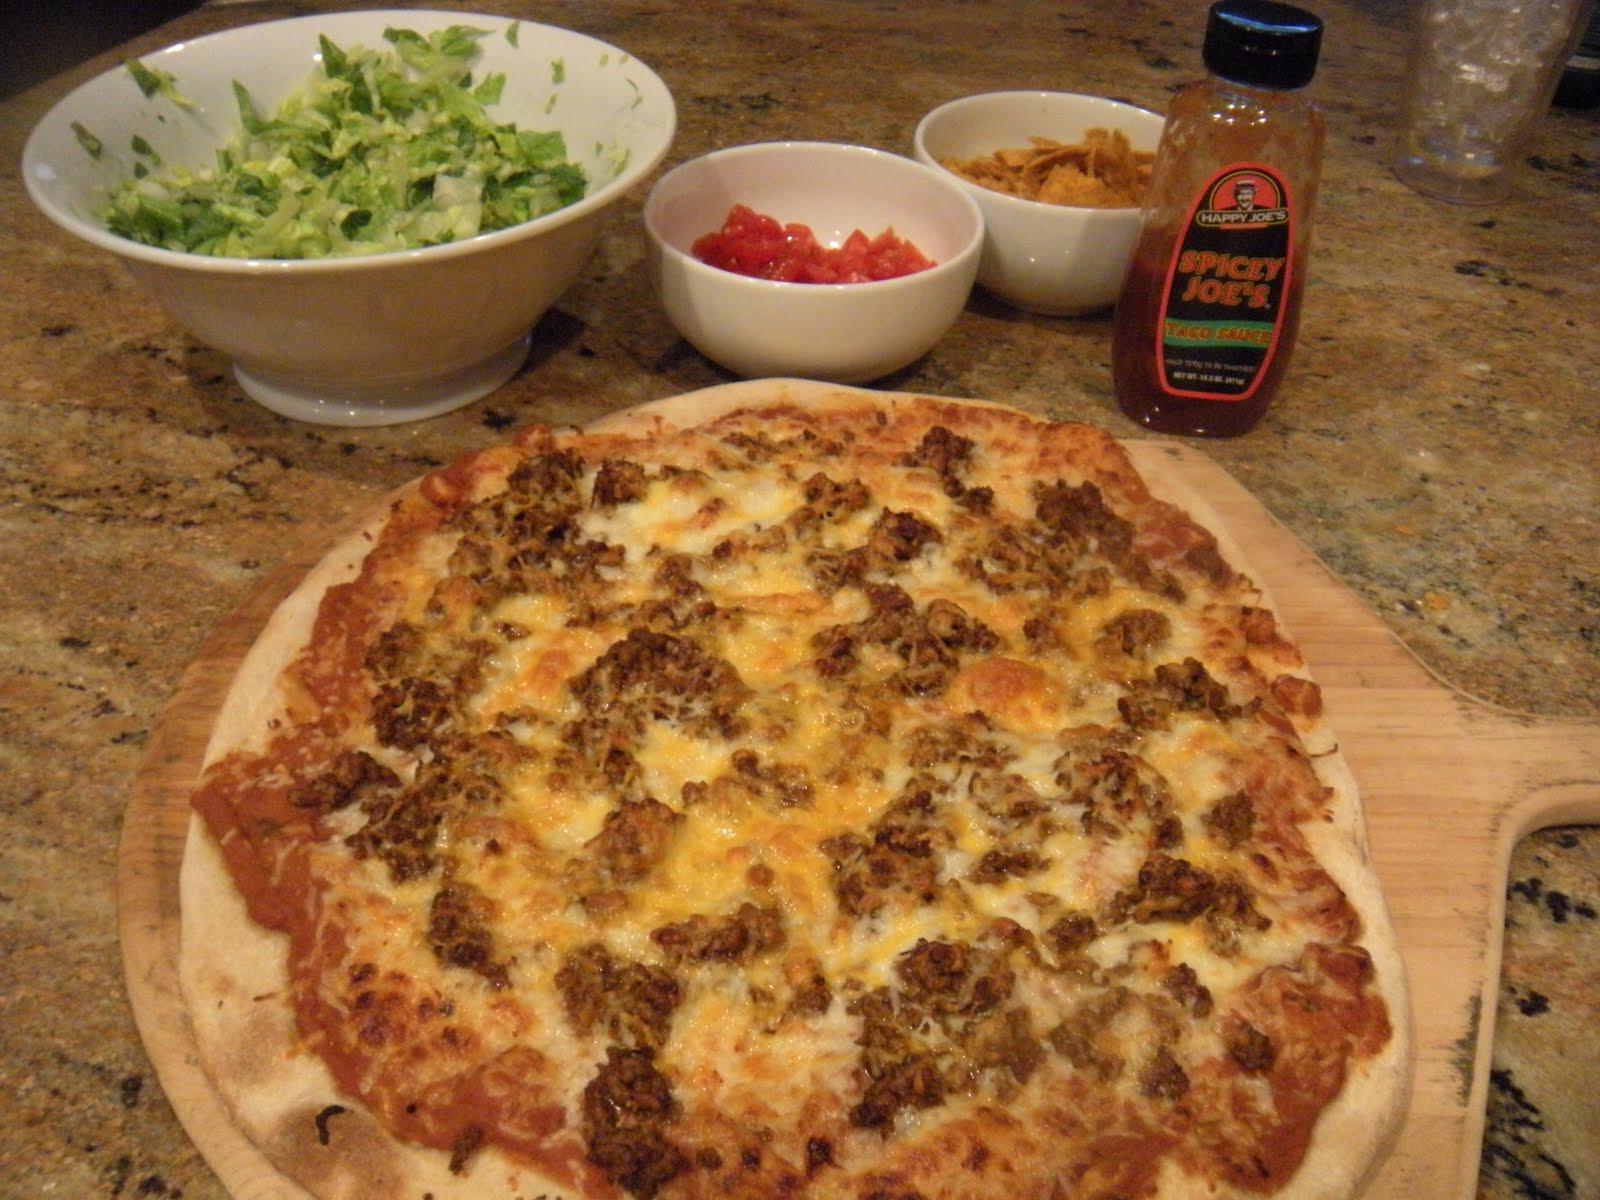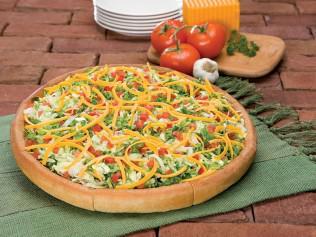The first image is the image on the left, the second image is the image on the right. Given the left and right images, does the statement "There is one whole pizza in the right image." hold true? Answer yes or no. Yes. The first image is the image on the left, the second image is the image on the right. Evaluate the accuracy of this statement regarding the images: "One of the pizzas is placed next to some fresh uncut tomatoes.". Is it true? Answer yes or no. Yes. 